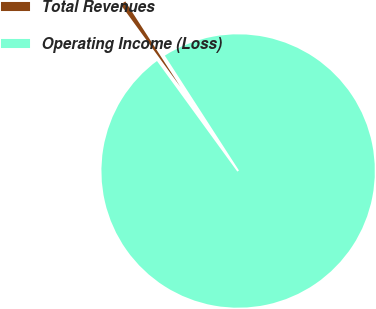Convert chart to OTSL. <chart><loc_0><loc_0><loc_500><loc_500><pie_chart><fcel>Total Revenues<fcel>Operating Income (Loss)<nl><fcel>0.88%<fcel>99.12%<nl></chart> 